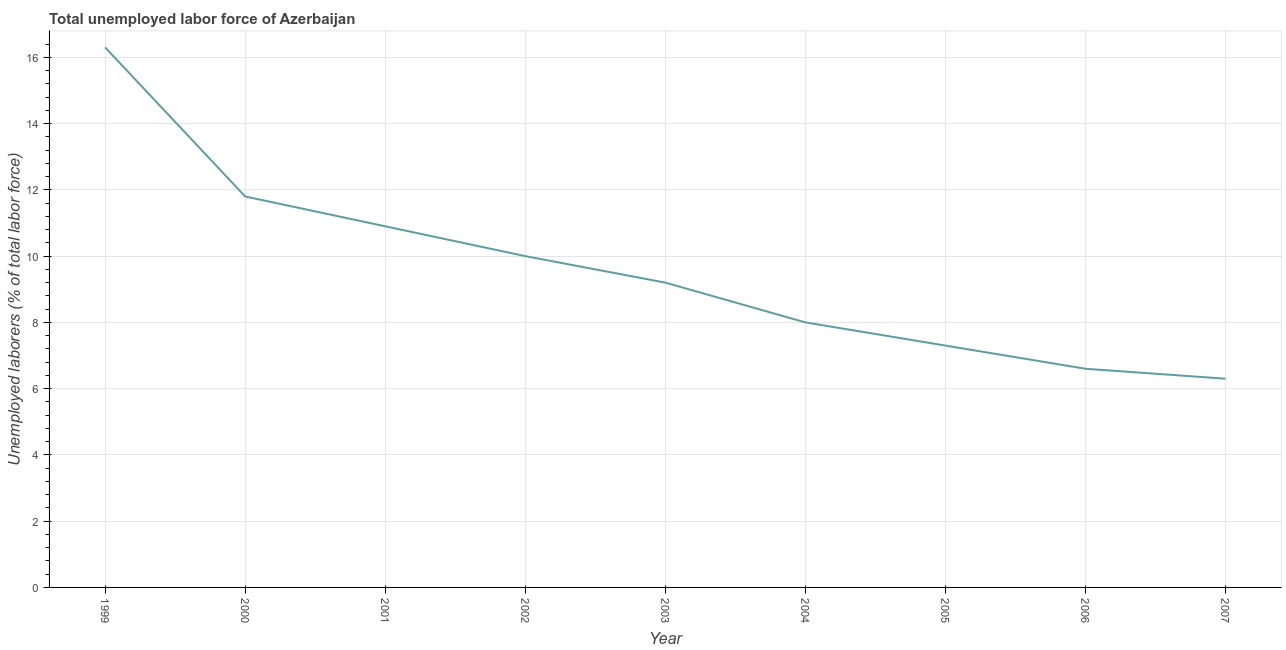What is the total unemployed labour force in 2003?
Keep it short and to the point. 9.2. Across all years, what is the maximum total unemployed labour force?
Your answer should be compact. 16.3. Across all years, what is the minimum total unemployed labour force?
Offer a terse response. 6.3. In which year was the total unemployed labour force maximum?
Provide a short and direct response. 1999. What is the sum of the total unemployed labour force?
Provide a succinct answer. 86.4. What is the difference between the total unemployed labour force in 1999 and 2005?
Your response must be concise. 9. What is the average total unemployed labour force per year?
Your answer should be compact. 9.6. What is the median total unemployed labour force?
Make the answer very short. 9.2. In how many years, is the total unemployed labour force greater than 15.2 %?
Make the answer very short. 1. Do a majority of the years between 2006 and 2004 (inclusive) have total unemployed labour force greater than 15.2 %?
Offer a very short reply. No. What is the ratio of the total unemployed labour force in 2005 to that in 2007?
Your response must be concise. 1.16. What is the difference between the highest and the second highest total unemployed labour force?
Ensure brevity in your answer.  4.5. What is the difference between the highest and the lowest total unemployed labour force?
Provide a short and direct response. 10. In how many years, is the total unemployed labour force greater than the average total unemployed labour force taken over all years?
Provide a succinct answer. 4. Does the graph contain any zero values?
Make the answer very short. No. Does the graph contain grids?
Offer a terse response. Yes. What is the title of the graph?
Give a very brief answer. Total unemployed labor force of Azerbaijan. What is the label or title of the Y-axis?
Your answer should be very brief. Unemployed laborers (% of total labor force). What is the Unemployed laborers (% of total labor force) of 1999?
Your response must be concise. 16.3. What is the Unemployed laborers (% of total labor force) in 2000?
Your response must be concise. 11.8. What is the Unemployed laborers (% of total labor force) in 2001?
Make the answer very short. 10.9. What is the Unemployed laborers (% of total labor force) of 2003?
Provide a succinct answer. 9.2. What is the Unemployed laborers (% of total labor force) of 2005?
Your answer should be very brief. 7.3. What is the Unemployed laborers (% of total labor force) of 2006?
Make the answer very short. 6.6. What is the Unemployed laborers (% of total labor force) of 2007?
Offer a very short reply. 6.3. What is the difference between the Unemployed laborers (% of total labor force) in 1999 and 2001?
Give a very brief answer. 5.4. What is the difference between the Unemployed laborers (% of total labor force) in 1999 and 2003?
Keep it short and to the point. 7.1. What is the difference between the Unemployed laborers (% of total labor force) in 2000 and 2001?
Provide a succinct answer. 0.9. What is the difference between the Unemployed laborers (% of total labor force) in 2000 and 2005?
Make the answer very short. 4.5. What is the difference between the Unemployed laborers (% of total labor force) in 2000 and 2006?
Offer a terse response. 5.2. What is the difference between the Unemployed laborers (% of total labor force) in 2001 and 2003?
Provide a short and direct response. 1.7. What is the difference between the Unemployed laborers (% of total labor force) in 2001 and 2004?
Provide a succinct answer. 2.9. What is the difference between the Unemployed laborers (% of total labor force) in 2001 and 2005?
Offer a very short reply. 3.6. What is the difference between the Unemployed laborers (% of total labor force) in 2001 and 2007?
Ensure brevity in your answer.  4.6. What is the difference between the Unemployed laborers (% of total labor force) in 2002 and 2007?
Offer a terse response. 3.7. What is the difference between the Unemployed laborers (% of total labor force) in 2003 and 2004?
Keep it short and to the point. 1.2. What is the difference between the Unemployed laborers (% of total labor force) in 2003 and 2006?
Offer a terse response. 2.6. What is the difference between the Unemployed laborers (% of total labor force) in 2004 and 2005?
Provide a short and direct response. 0.7. What is the difference between the Unemployed laborers (% of total labor force) in 2004 and 2006?
Provide a short and direct response. 1.4. What is the difference between the Unemployed laborers (% of total labor force) in 2005 and 2006?
Ensure brevity in your answer.  0.7. What is the difference between the Unemployed laborers (% of total labor force) in 2005 and 2007?
Make the answer very short. 1. What is the difference between the Unemployed laborers (% of total labor force) in 2006 and 2007?
Make the answer very short. 0.3. What is the ratio of the Unemployed laborers (% of total labor force) in 1999 to that in 2000?
Your answer should be very brief. 1.38. What is the ratio of the Unemployed laborers (% of total labor force) in 1999 to that in 2001?
Keep it short and to the point. 1.5. What is the ratio of the Unemployed laborers (% of total labor force) in 1999 to that in 2002?
Provide a short and direct response. 1.63. What is the ratio of the Unemployed laborers (% of total labor force) in 1999 to that in 2003?
Your answer should be compact. 1.77. What is the ratio of the Unemployed laborers (% of total labor force) in 1999 to that in 2004?
Provide a short and direct response. 2.04. What is the ratio of the Unemployed laborers (% of total labor force) in 1999 to that in 2005?
Your answer should be compact. 2.23. What is the ratio of the Unemployed laborers (% of total labor force) in 1999 to that in 2006?
Ensure brevity in your answer.  2.47. What is the ratio of the Unemployed laborers (% of total labor force) in 1999 to that in 2007?
Your answer should be compact. 2.59. What is the ratio of the Unemployed laborers (% of total labor force) in 2000 to that in 2001?
Offer a very short reply. 1.08. What is the ratio of the Unemployed laborers (% of total labor force) in 2000 to that in 2002?
Ensure brevity in your answer.  1.18. What is the ratio of the Unemployed laborers (% of total labor force) in 2000 to that in 2003?
Your answer should be very brief. 1.28. What is the ratio of the Unemployed laborers (% of total labor force) in 2000 to that in 2004?
Your answer should be very brief. 1.48. What is the ratio of the Unemployed laborers (% of total labor force) in 2000 to that in 2005?
Give a very brief answer. 1.62. What is the ratio of the Unemployed laborers (% of total labor force) in 2000 to that in 2006?
Provide a succinct answer. 1.79. What is the ratio of the Unemployed laborers (% of total labor force) in 2000 to that in 2007?
Make the answer very short. 1.87. What is the ratio of the Unemployed laborers (% of total labor force) in 2001 to that in 2002?
Your answer should be very brief. 1.09. What is the ratio of the Unemployed laborers (% of total labor force) in 2001 to that in 2003?
Ensure brevity in your answer.  1.19. What is the ratio of the Unemployed laborers (% of total labor force) in 2001 to that in 2004?
Make the answer very short. 1.36. What is the ratio of the Unemployed laborers (% of total labor force) in 2001 to that in 2005?
Ensure brevity in your answer.  1.49. What is the ratio of the Unemployed laborers (% of total labor force) in 2001 to that in 2006?
Ensure brevity in your answer.  1.65. What is the ratio of the Unemployed laborers (% of total labor force) in 2001 to that in 2007?
Keep it short and to the point. 1.73. What is the ratio of the Unemployed laborers (% of total labor force) in 2002 to that in 2003?
Your response must be concise. 1.09. What is the ratio of the Unemployed laborers (% of total labor force) in 2002 to that in 2005?
Keep it short and to the point. 1.37. What is the ratio of the Unemployed laborers (% of total labor force) in 2002 to that in 2006?
Offer a terse response. 1.51. What is the ratio of the Unemployed laborers (% of total labor force) in 2002 to that in 2007?
Your response must be concise. 1.59. What is the ratio of the Unemployed laborers (% of total labor force) in 2003 to that in 2004?
Offer a very short reply. 1.15. What is the ratio of the Unemployed laborers (% of total labor force) in 2003 to that in 2005?
Keep it short and to the point. 1.26. What is the ratio of the Unemployed laborers (% of total labor force) in 2003 to that in 2006?
Ensure brevity in your answer.  1.39. What is the ratio of the Unemployed laborers (% of total labor force) in 2003 to that in 2007?
Ensure brevity in your answer.  1.46. What is the ratio of the Unemployed laborers (% of total labor force) in 2004 to that in 2005?
Provide a short and direct response. 1.1. What is the ratio of the Unemployed laborers (% of total labor force) in 2004 to that in 2006?
Ensure brevity in your answer.  1.21. What is the ratio of the Unemployed laborers (% of total labor force) in 2004 to that in 2007?
Give a very brief answer. 1.27. What is the ratio of the Unemployed laborers (% of total labor force) in 2005 to that in 2006?
Provide a short and direct response. 1.11. What is the ratio of the Unemployed laborers (% of total labor force) in 2005 to that in 2007?
Make the answer very short. 1.16. What is the ratio of the Unemployed laborers (% of total labor force) in 2006 to that in 2007?
Provide a succinct answer. 1.05. 